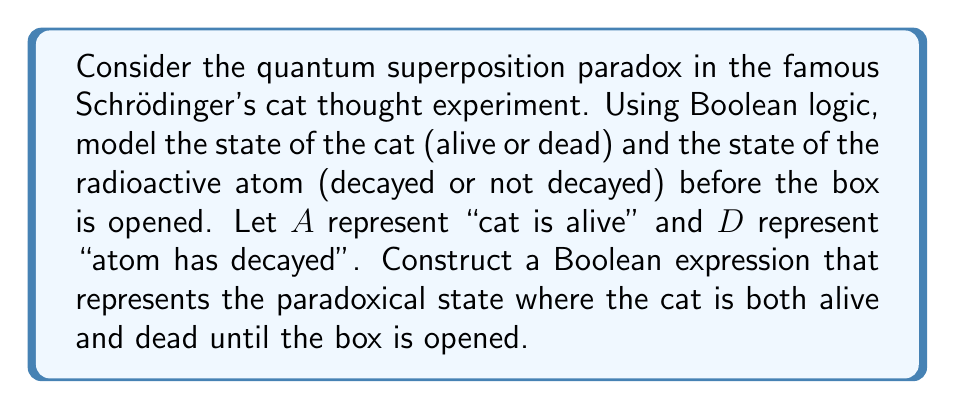Could you help me with this problem? Let's approach this step-by-step:

1) In Boolean logic, we can represent the cat's state as:
   $A$: cat is alive
   $\neg A$: cat is not alive (dead)

2) For the radioactive atom:
   $D$: atom has decayed
   $\neg D$: atom has not decayed

3) In the unopened box, the atom is in a superposition of decayed and not decayed states. We can represent this as:
   $$(D \wedge \neg D)$$

4) The cat's state is directly linked to the atom's state:
   - If the atom decays, the cat dies: $D \rightarrow \neg A$
   - If the atom doesn't decay, the cat lives: $\neg D \rightarrow A$

5) The paradoxical state where the cat is both alive and dead can be represented as:
   $$(A \wedge \neg A)$$

6) To model the entire system, we need to combine the atom's superposition with the cat's paradoxical state:
   $$((D \wedge \neg D) \wedge (A \wedge \neg A))$$

7) This expression represents the quantum superposition where the atom is both decayed and not decayed, and consequently, the cat is both alive and dead until the box is opened and the system is observed.

8) It's important to note that this Boolean expression is always false in classical logic, which highlights the paradoxical nature of quantum superposition when applied to macroscopic objects.
Answer: $((D \wedge \neg D) \wedge (A \wedge \neg A))$ 